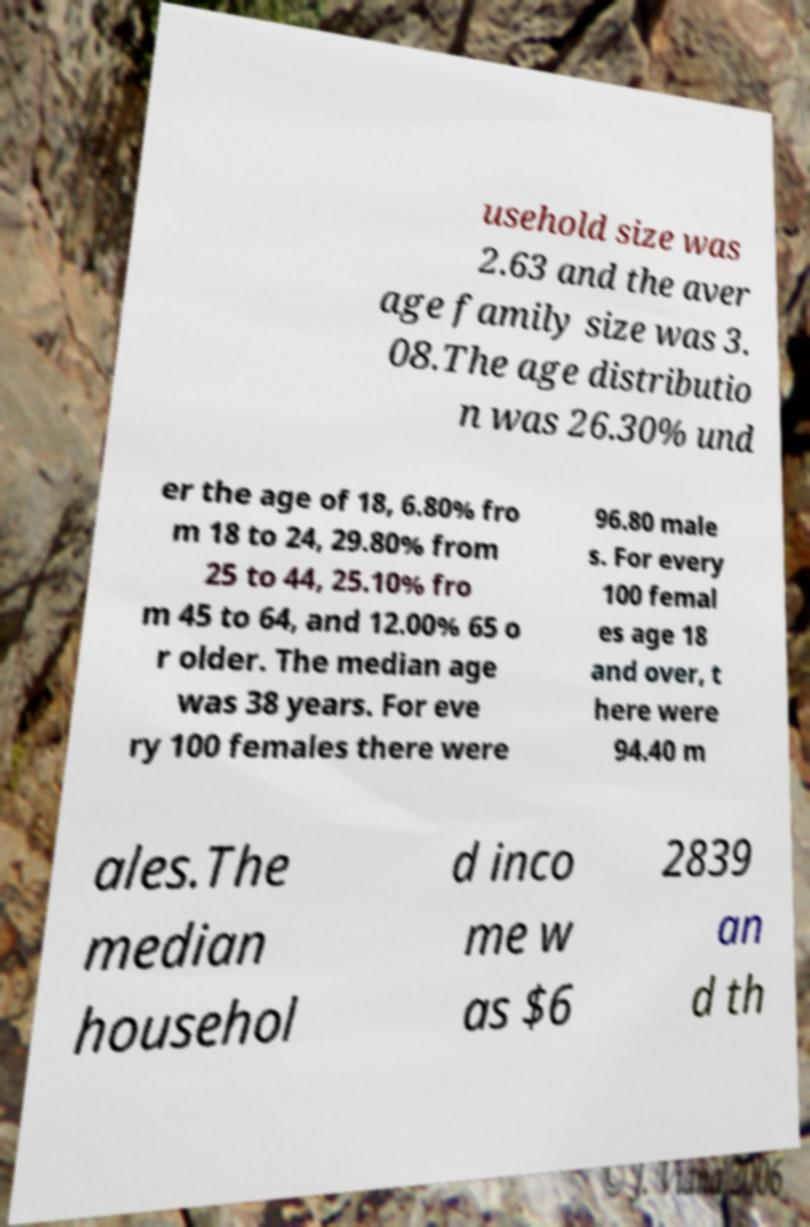Can you accurately transcribe the text from the provided image for me? usehold size was 2.63 and the aver age family size was 3. 08.The age distributio n was 26.30% und er the age of 18, 6.80% fro m 18 to 24, 29.80% from 25 to 44, 25.10% fro m 45 to 64, and 12.00% 65 o r older. The median age was 38 years. For eve ry 100 females there were 96.80 male s. For every 100 femal es age 18 and over, t here were 94.40 m ales.The median househol d inco me w as $6 2839 an d th 